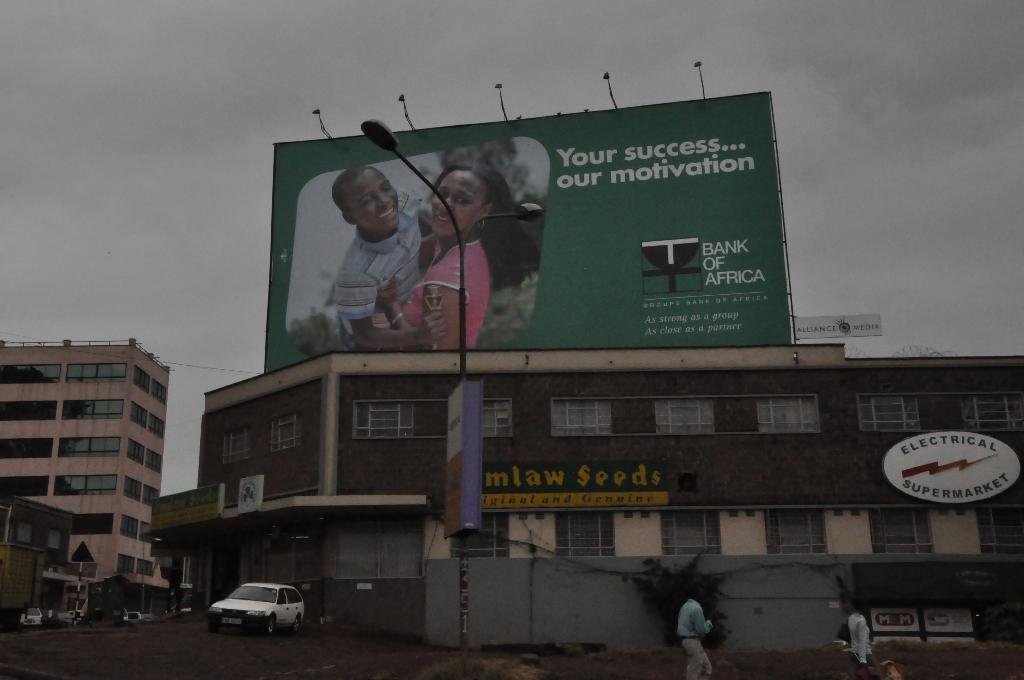<image>
Write a terse but informative summary of the picture. An ad for Bank of Africa above a building. 